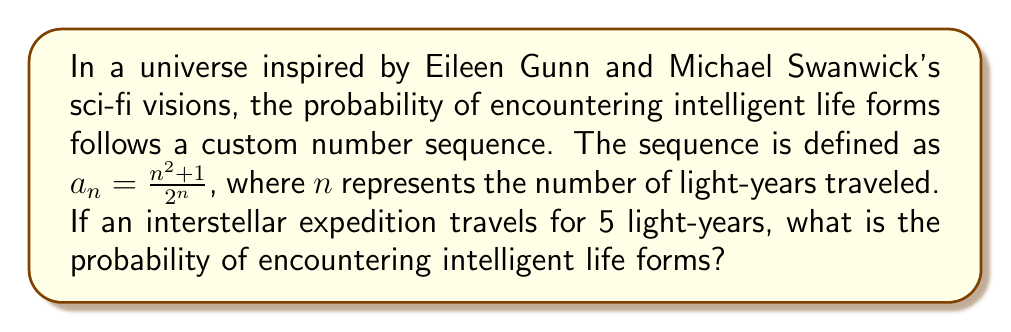Help me with this question. To solve this problem, we need to follow these steps:

1) The sequence is given by $a_n = \frac{n^2 + 1}{2^n}$

2) We need to find $a_5$ since the expedition travels for 5 light-years

3) Let's substitute $n = 5$ into the formula:

   $a_5 = \frac{5^2 + 1}{2^5}$

4) Simplify the numerator:
   $a_5 = \frac{25 + 1}{2^5} = \frac{26}{2^5}$

5) Calculate $2^5$:
   $2^5 = 2 \times 2 \times 2 \times 2 \times 2 = 32$

6) Therefore:
   $a_5 = \frac{26}{32}$

7) This fraction can be reduced:
   $a_5 = \frac{13}{16}$

This result, $\frac{13}{16}$, represents the probability of encountering intelligent life forms after traveling 5 light-years in this sci-fi inspired universe.
Answer: $\frac{13}{16}$ 